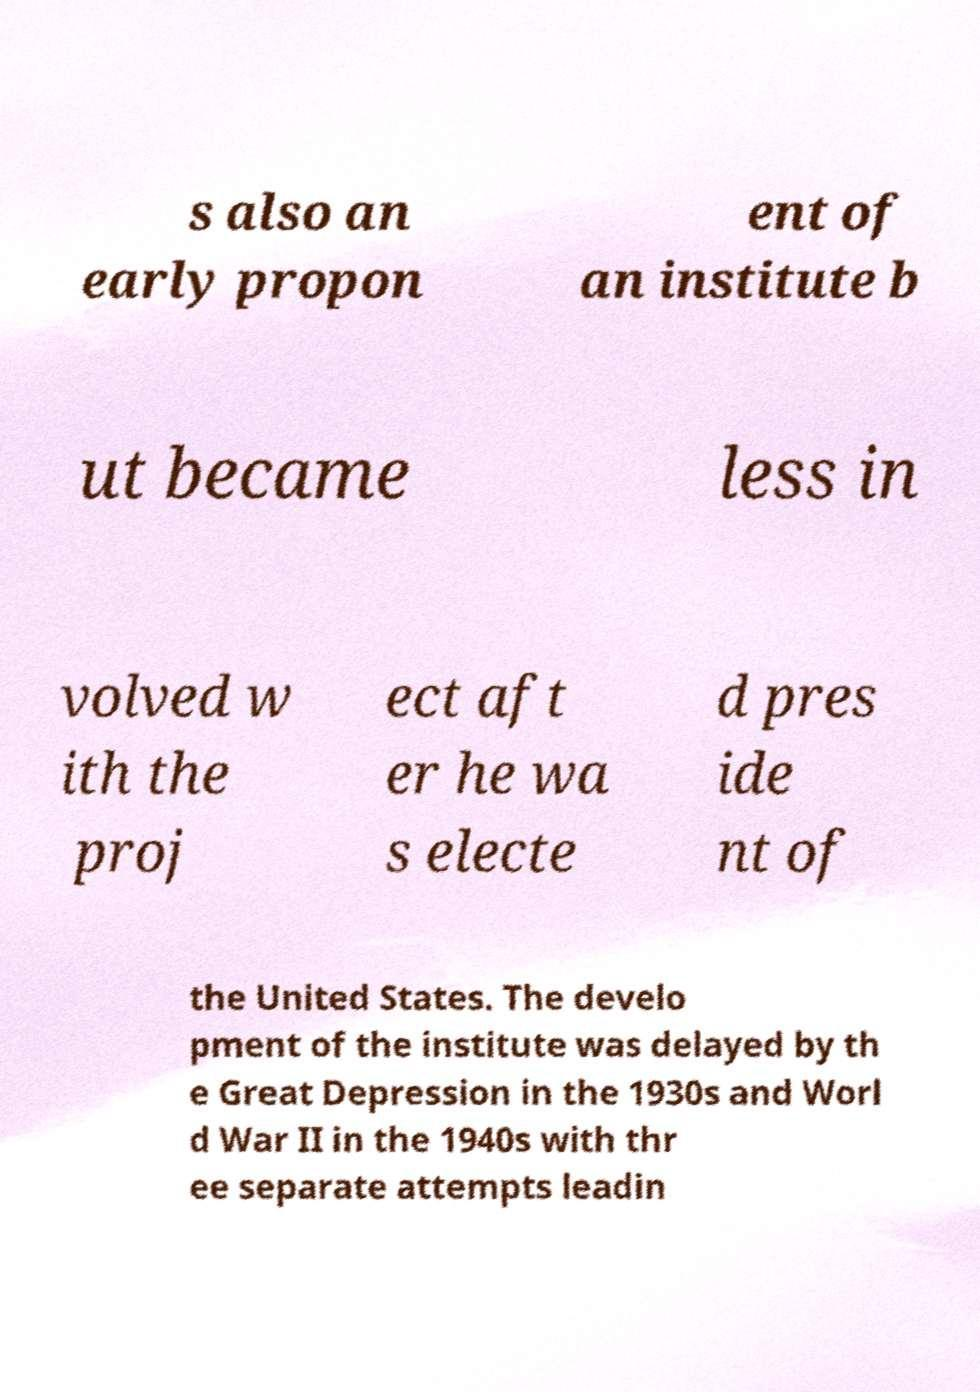Can you read and provide the text displayed in the image?This photo seems to have some interesting text. Can you extract and type it out for me? s also an early propon ent of an institute b ut became less in volved w ith the proj ect aft er he wa s electe d pres ide nt of the United States. The develo pment of the institute was delayed by th e Great Depression in the 1930s and Worl d War II in the 1940s with thr ee separate attempts leadin 